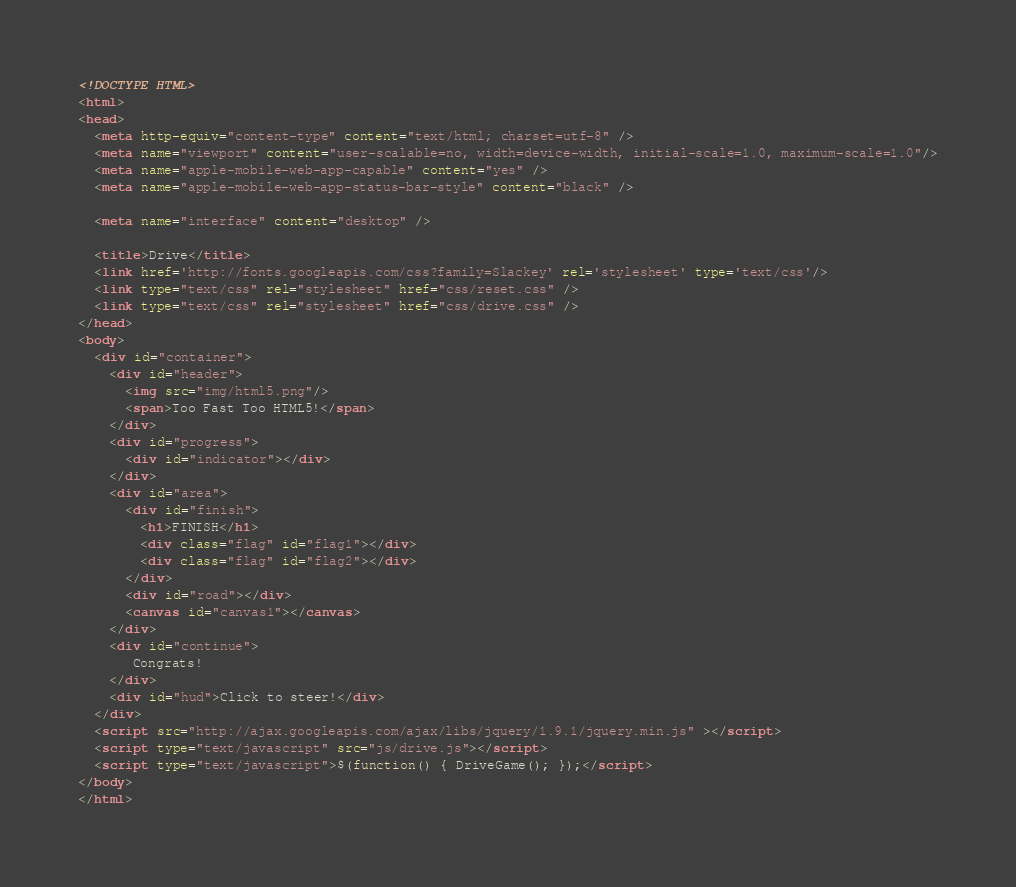Convert code to text. <code><loc_0><loc_0><loc_500><loc_500><_HTML_><!DOCTYPE HTML>
<html>
<head>
  <meta http-equiv="content-type" content="text/html; charset=utf-8" />
  <meta name="viewport" content="user-scalable=no, width=device-width, initial-scale=1.0, maximum-scale=1.0"/>
  <meta name="apple-mobile-web-app-capable" content="yes" />
  <meta name="apple-mobile-web-app-status-bar-style" content="black" />

  <meta name="interface" content="desktop" />

  <title>Drive</title>
  <link href='http://fonts.googleapis.com/css?family=Slackey' rel='stylesheet' type='text/css'/>
  <link type="text/css" rel="stylesheet" href="css/reset.css" />
  <link type="text/css" rel="stylesheet" href="css/drive.css" />
</head>
<body>
  <div id="container">
	<div id="header">
	  <img src="img/html5.png"/>
	  <span>Too Fast Too HTML5!</span>
	</div>
	<div id="progress">
	  <div id="indicator"></div>
	</div>
	<div id="area">
	  <div id="finish">
		<h1>FINISH</h1>
		<div class="flag" id="flag1"></div>
		<div class="flag" id="flag2"></div>
	  </div>
	  <div id="road"></div>
	  <canvas id="canvas1"></canvas>
	</div>	
	<div id="continue">
       Congrats!
	</div>
	<div id="hud">Click to steer!</div>
  </div>
  <script src="http://ajax.googleapis.com/ajax/libs/jquery/1.9.1/jquery.min.js" ></script>
  <script type="text/javascript" src="js/drive.js"></script>
  <script type="text/javascript">$(function() { DriveGame(); });</script>
</body>
</html></code> 